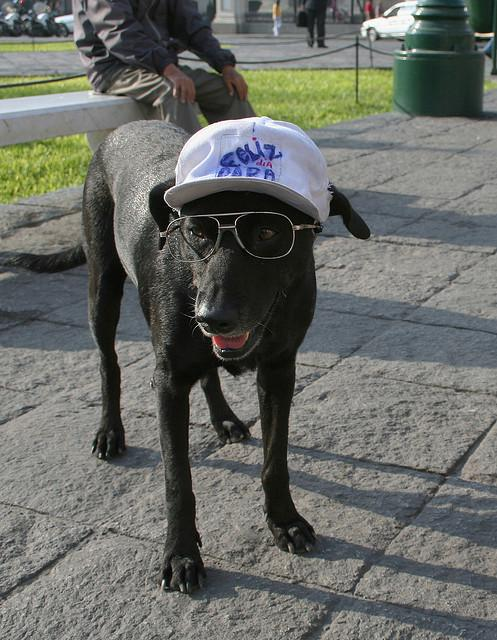What is the dog wearing? Please explain your reasoning. glasses. The dog has glasses on its eyes. 